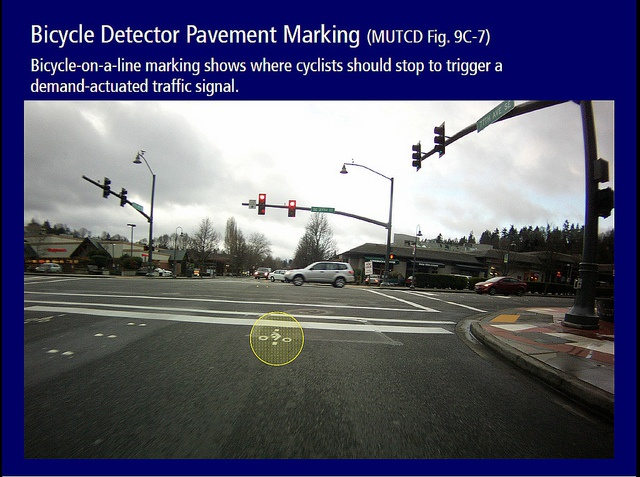Describe the objects in this image and their specific colors. I can see car in black, gray, darkgray, and lightgray tones, car in black, maroon, darkgray, and gray tones, traffic light in black, white, gray, and navy tones, car in black, gray, and darkgreen tones, and traffic light in black, darkgray, gray, and navy tones in this image. 